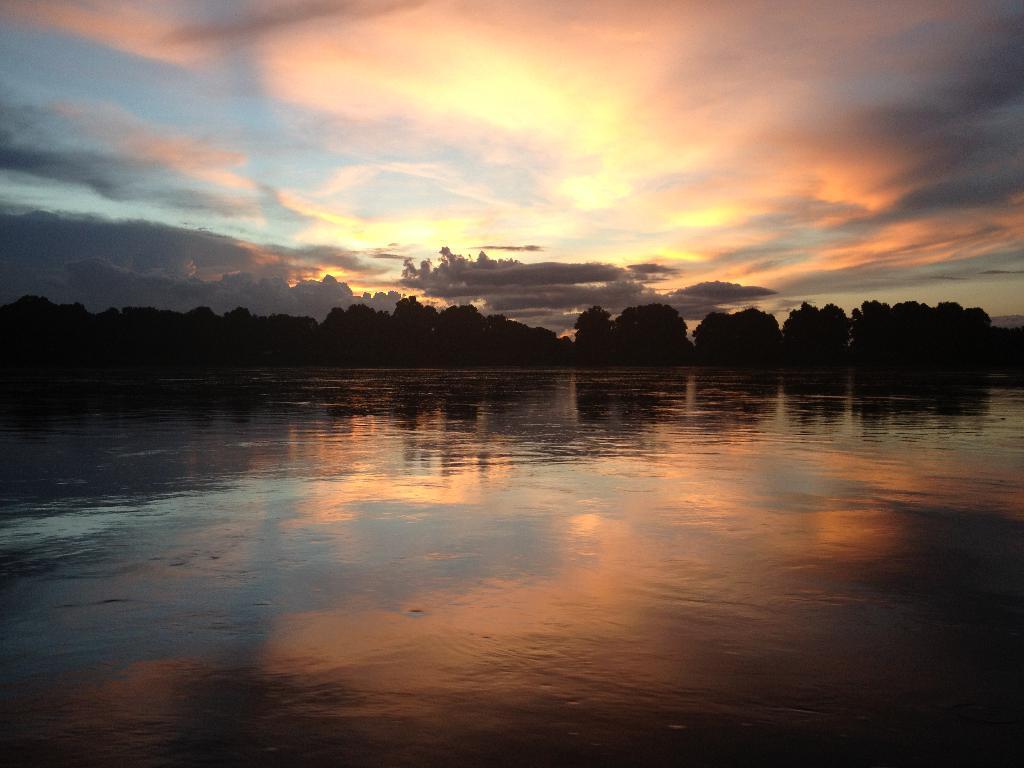In one or two sentences, can you explain what this image depicts? In this image we can see a group of trees are there, we can see a reflection of the sky on the water surface, the sky is slightly cloudy. 